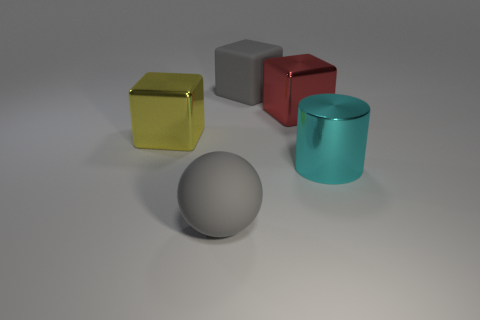Subtract all big metal cubes. How many cubes are left? 1 Subtract 1 cylinders. How many cylinders are left? 0 Add 3 large yellow shiny blocks. How many objects exist? 8 Subtract all blocks. How many objects are left? 2 Subtract all purple cylinders. How many yellow cubes are left? 1 Subtract all shiny objects. Subtract all big yellow objects. How many objects are left? 1 Add 4 big yellow metallic objects. How many big yellow metallic objects are left? 5 Add 3 large metal cylinders. How many large metal cylinders exist? 4 Subtract all yellow blocks. How many blocks are left? 2 Subtract 1 cyan cylinders. How many objects are left? 4 